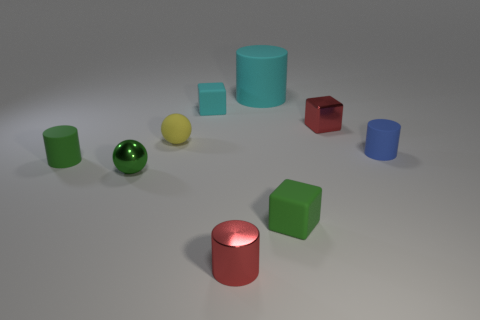There is a large matte cylinder; how many spheres are behind it? Observing the provided image, there are three spheres positioned behind the large matte cylinder. Each sphere flaunts its own distinct color: one green, one yellow, and one blue, contributing to the variety in hues displayed in the scene. 